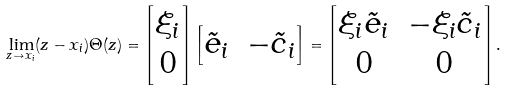Convert formula to latex. <formula><loc_0><loc_0><loc_500><loc_500>\lim _ { z \to x _ { i } } ( z - x _ { i } ) \Theta ( z ) = \begin{bmatrix} \xi _ { i } \\ 0 \end{bmatrix} \begin{bmatrix} \tilde { e } _ { i } & - \tilde { c } _ { i } \end{bmatrix} = \begin{bmatrix} \xi _ { i } \tilde { e } _ { i } & - \xi _ { i } \tilde { c } _ { i } \\ 0 & 0 \end{bmatrix} .</formula> 